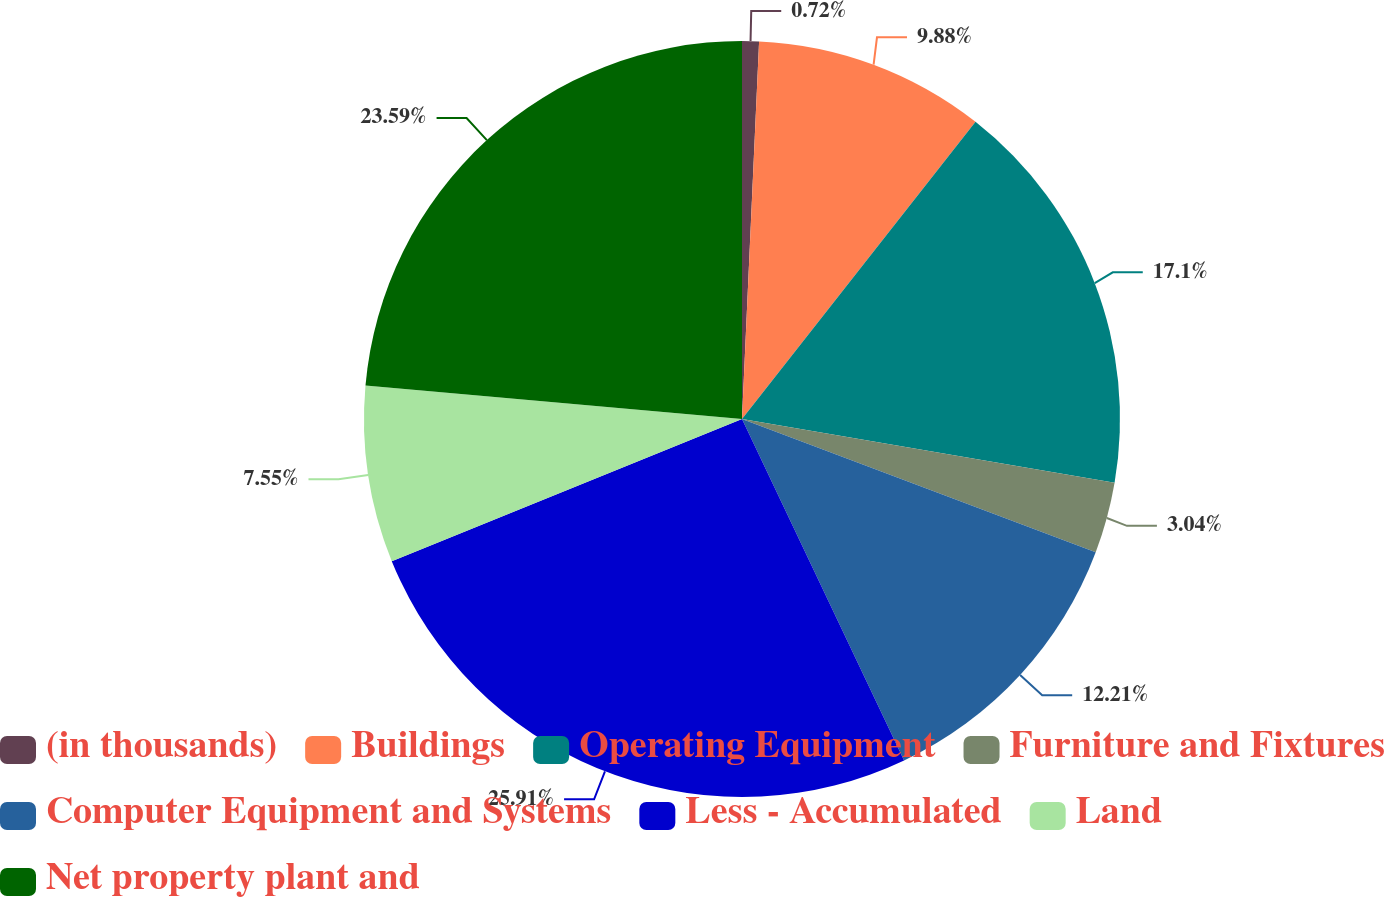Convert chart. <chart><loc_0><loc_0><loc_500><loc_500><pie_chart><fcel>(in thousands)<fcel>Buildings<fcel>Operating Equipment<fcel>Furniture and Fixtures<fcel>Computer Equipment and Systems<fcel>Less - Accumulated<fcel>Land<fcel>Net property plant and<nl><fcel>0.72%<fcel>9.88%<fcel>17.1%<fcel>3.04%<fcel>12.21%<fcel>25.92%<fcel>7.55%<fcel>23.59%<nl></chart> 